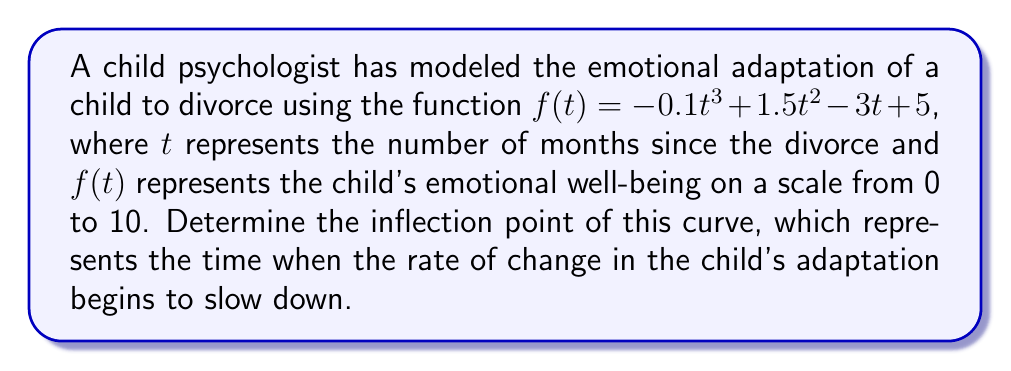Give your solution to this math problem. To find the inflection point, we need to follow these steps:

1) The inflection point occurs where the second derivative of the function equals zero.

2) First, let's find the first derivative:
   $$f'(t) = -0.3t^2 + 3t - 3$$

3) Now, let's find the second derivative:
   $$f''(t) = -0.6t + 3$$

4) Set the second derivative equal to zero and solve for t:
   $$-0.6t + 3 = 0$$
   $$-0.6t = -3$$
   $$t = 5$$

5) To confirm this is an inflection point, we need to verify that the second derivative changes sign at this point:
   
   When $t < 5$, $f''(t) > 0$
   When $t > 5$, $f''(t) < 0$

6) Therefore, $t = 5$ is indeed the inflection point.

7) To find the corresponding y-value, we plug $t = 5$ into the original function:
   $$f(5) = -0.1(5)^3 + 1.5(5)^2 - 3(5) + 5$$
   $$= -12.5 + 37.5 - 15 + 5 = 15$$

Thus, the inflection point occurs at (5, 15).
Answer: (5, 15) 